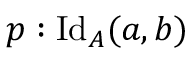<formula> <loc_0><loc_0><loc_500><loc_500>p \colon I d _ { A } ( a , b )</formula> 